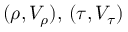Convert formula to latex. <formula><loc_0><loc_0><loc_500><loc_500>( \rho , V _ { \rho } ) , \, ( \tau , V _ { \tau } )</formula> 